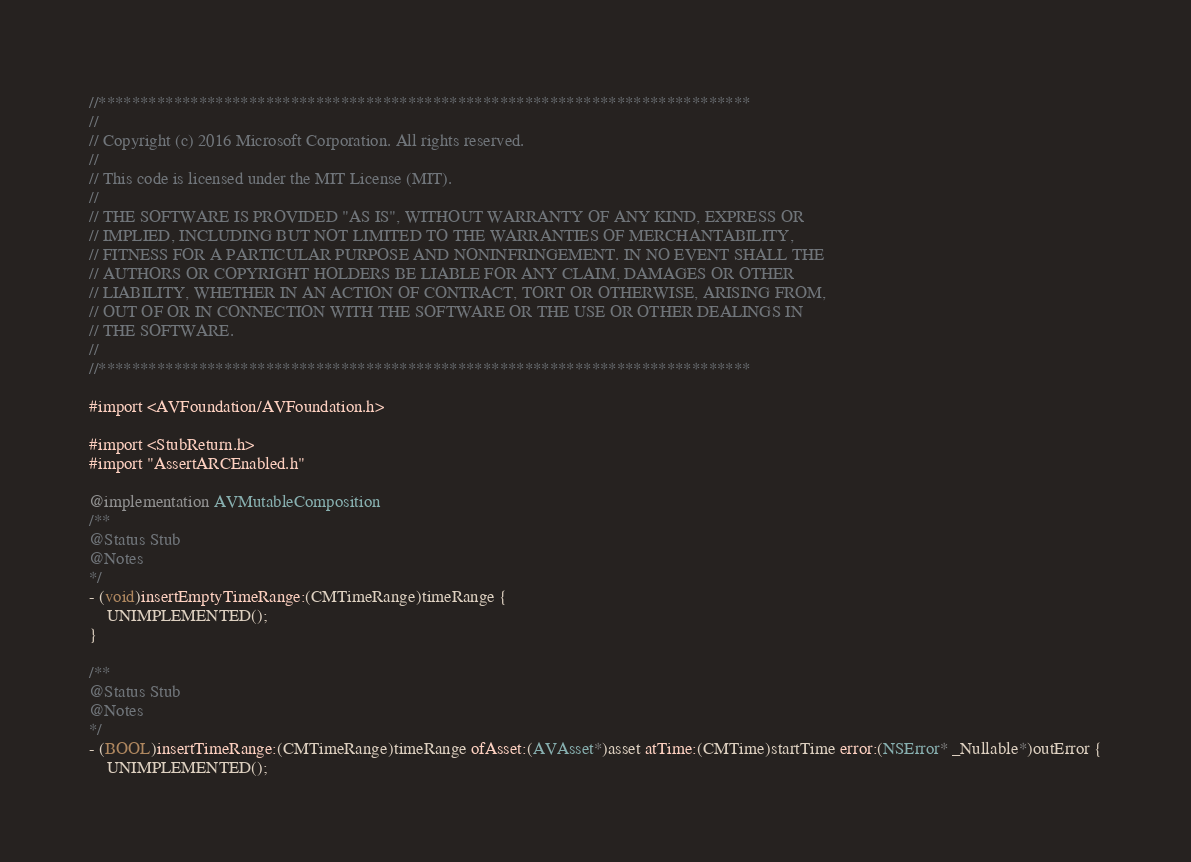<code> <loc_0><loc_0><loc_500><loc_500><_ObjectiveC_>//******************************************************************************
//
// Copyright (c) 2016 Microsoft Corporation. All rights reserved.
//
// This code is licensed under the MIT License (MIT).
//
// THE SOFTWARE IS PROVIDED "AS IS", WITHOUT WARRANTY OF ANY KIND, EXPRESS OR
// IMPLIED, INCLUDING BUT NOT LIMITED TO THE WARRANTIES OF MERCHANTABILITY,
// FITNESS FOR A PARTICULAR PURPOSE AND NONINFRINGEMENT. IN NO EVENT SHALL THE
// AUTHORS OR COPYRIGHT HOLDERS BE LIABLE FOR ANY CLAIM, DAMAGES OR OTHER
// LIABILITY, WHETHER IN AN ACTION OF CONTRACT, TORT OR OTHERWISE, ARISING FROM,
// OUT OF OR IN CONNECTION WITH THE SOFTWARE OR THE USE OR OTHER DEALINGS IN
// THE SOFTWARE.
//
//******************************************************************************

#import <AVFoundation/AVFoundation.h>

#import <StubReturn.h>
#import "AssertARCEnabled.h"

@implementation AVMutableComposition
/**
@Status Stub
@Notes
*/
- (void)insertEmptyTimeRange:(CMTimeRange)timeRange {
    UNIMPLEMENTED();
}

/**
@Status Stub
@Notes
*/
- (BOOL)insertTimeRange:(CMTimeRange)timeRange ofAsset:(AVAsset*)asset atTime:(CMTime)startTime error:(NSError* _Nullable*)outError {
    UNIMPLEMENTED();</code> 